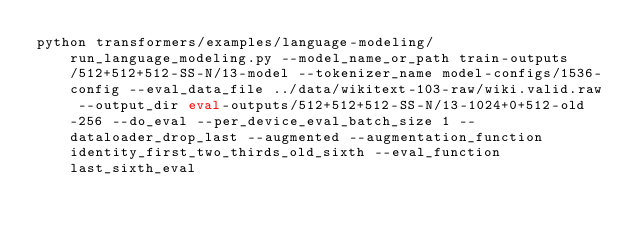Convert code to text. <code><loc_0><loc_0><loc_500><loc_500><_Bash_>python transformers/examples/language-modeling/run_language_modeling.py --model_name_or_path train-outputs/512+512+512-SS-N/13-model --tokenizer_name model-configs/1536-config --eval_data_file ../data/wikitext-103-raw/wiki.valid.raw --output_dir eval-outputs/512+512+512-SS-N/13-1024+0+512-old-256 --do_eval --per_device_eval_batch_size 1 --dataloader_drop_last --augmented --augmentation_function identity_first_two_thirds_old_sixth --eval_function last_sixth_eval</code> 